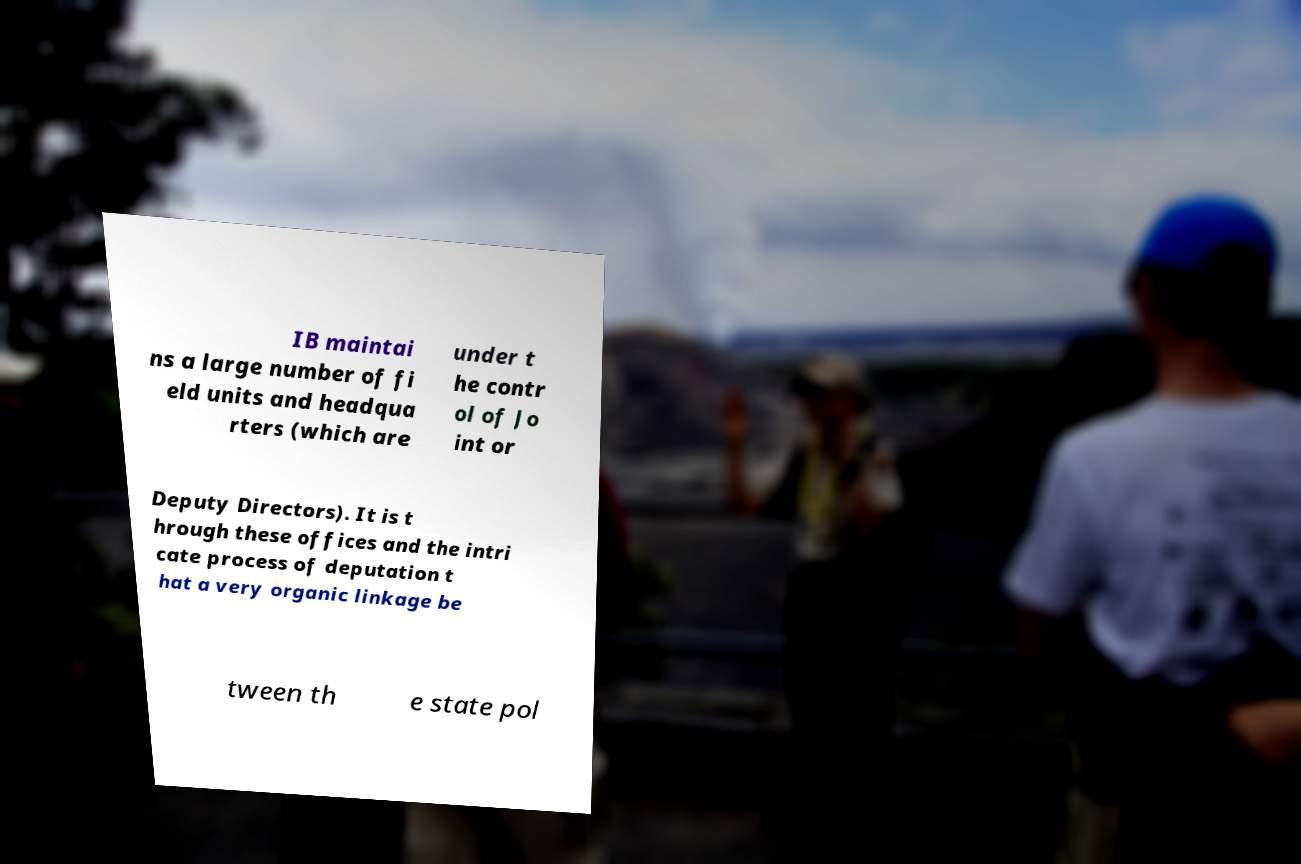Can you read and provide the text displayed in the image?This photo seems to have some interesting text. Can you extract and type it out for me? IB maintai ns a large number of fi eld units and headqua rters (which are under t he contr ol of Jo int or Deputy Directors). It is t hrough these offices and the intri cate process of deputation t hat a very organic linkage be tween th e state pol 